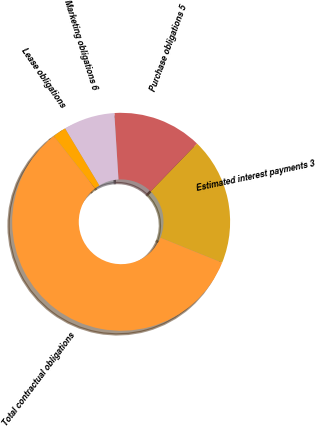Convert chart. <chart><loc_0><loc_0><loc_500><loc_500><pie_chart><fcel>Estimated interest payments 3<fcel>Purchase obligations 5<fcel>Marketing obligations 6<fcel>Lease obligations<fcel>Total contractual obligations<nl><fcel>18.87%<fcel>13.25%<fcel>7.62%<fcel>1.99%<fcel>58.27%<nl></chart> 